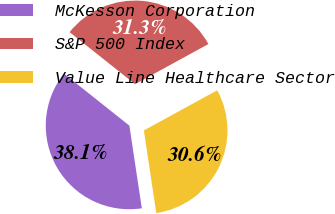Convert chart to OTSL. <chart><loc_0><loc_0><loc_500><loc_500><pie_chart><fcel>McKesson Corporation<fcel>S&P 500 Index<fcel>Value Line Healthcare Sector<nl><fcel>38.07%<fcel>31.34%<fcel>30.59%<nl></chart> 